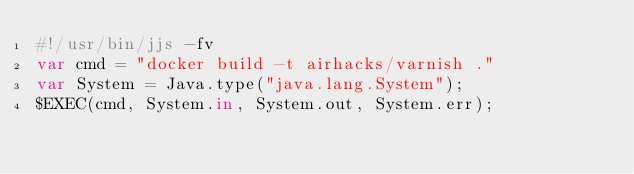<code> <loc_0><loc_0><loc_500><loc_500><_JavaScript_>#!/usr/bin/jjs -fv
var cmd = "docker build -t airhacks/varnish ."
var System = Java.type("java.lang.System");
$EXEC(cmd, System.in, System.out, System.err);</code> 